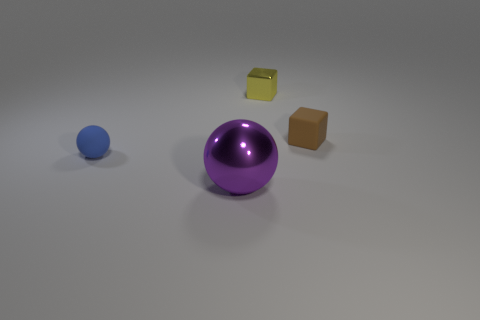Add 2 tiny gray rubber objects. How many objects exist? 6 Subtract 0 cyan cylinders. How many objects are left? 4 Subtract all small cyan metal things. Subtract all brown rubber blocks. How many objects are left? 3 Add 3 matte cubes. How many matte cubes are left? 4 Add 2 big purple objects. How many big purple objects exist? 3 